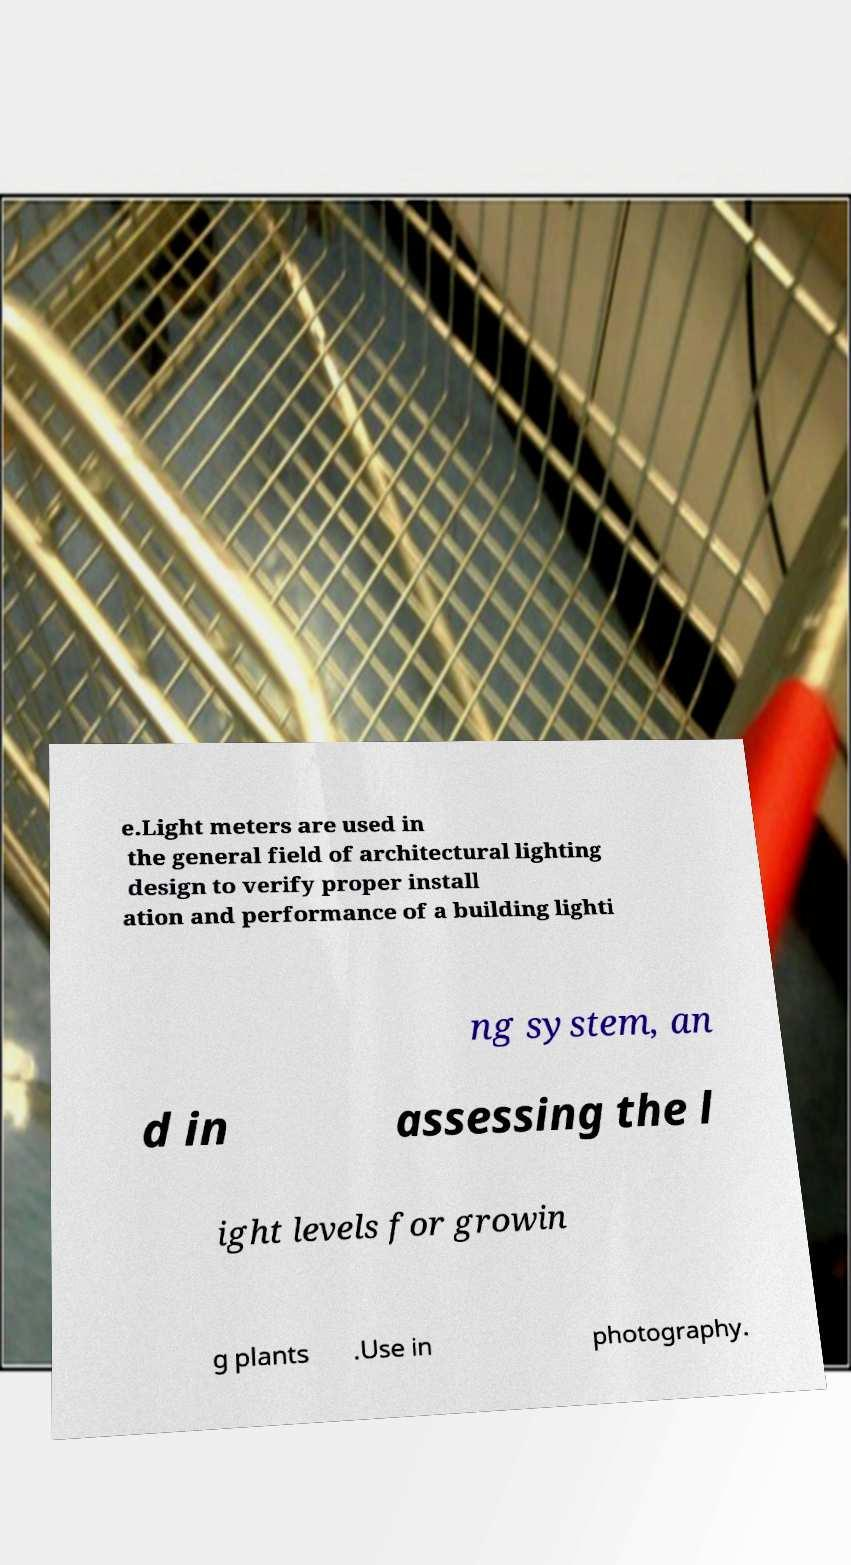For documentation purposes, I need the text within this image transcribed. Could you provide that? e.Light meters are used in the general field of architectural lighting design to verify proper install ation and performance of a building lighti ng system, an d in assessing the l ight levels for growin g plants .Use in photography. 